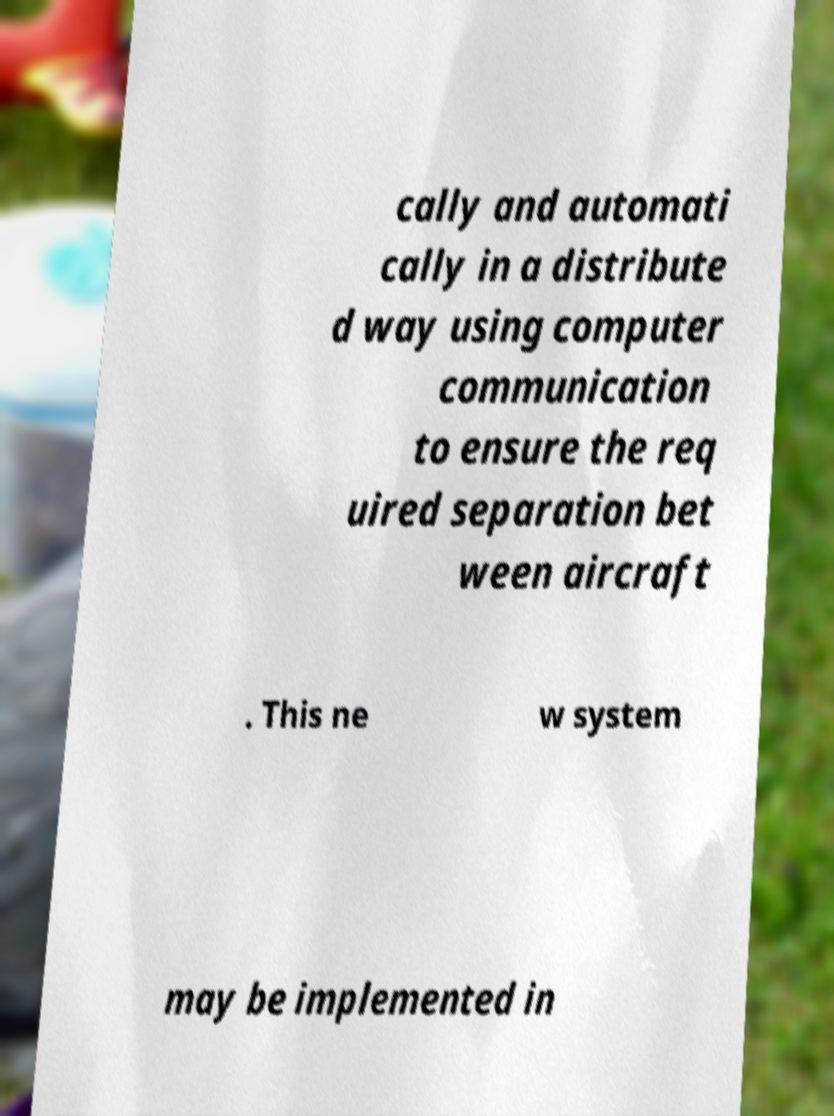Please read and relay the text visible in this image. What does it say? cally and automati cally in a distribute d way using computer communication to ensure the req uired separation bet ween aircraft . This ne w system may be implemented in 